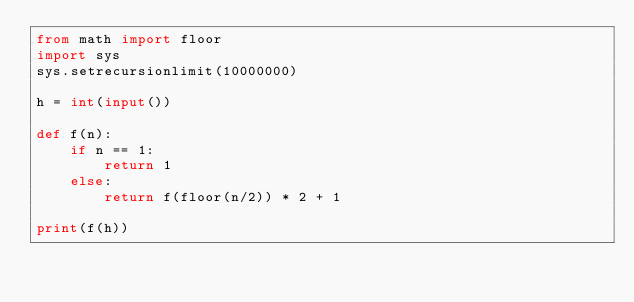<code> <loc_0><loc_0><loc_500><loc_500><_Python_>from math import floor
import sys
sys.setrecursionlimit(10000000)
 
h = int(input())
 
def f(n):
    if n == 1:
        return 1
    else:
        return f(floor(n/2)) * 2 + 1
 
print(f(h))
</code> 